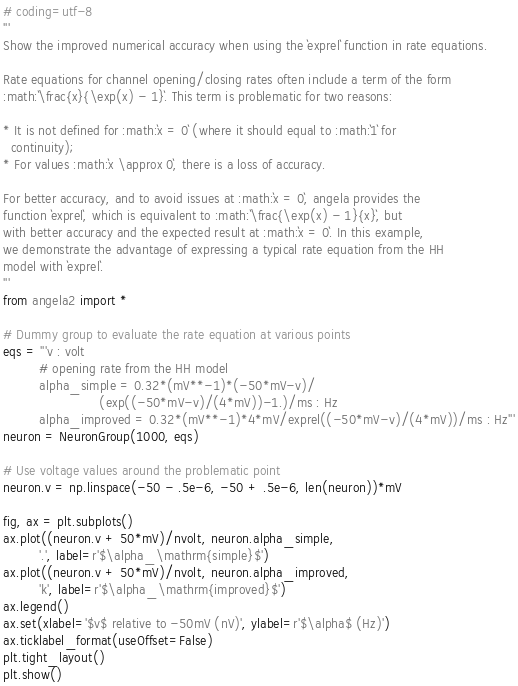<code> <loc_0><loc_0><loc_500><loc_500><_Python_># coding=utf-8
'''
Show the improved numerical accuracy when using the `exprel` function in rate equations.

Rate equations for channel opening/closing rates often include a term of the form
:math:`\frac{x}{\exp(x) - 1}`. This term is problematic for two reasons:

* It is not defined for :math:`x = 0` (where it should equal to :math:`1` for
  continuity);
* For values :math:`x \approx 0`, there is a loss of accuracy.

For better accuracy, and to avoid issues at :math:`x = 0`, angela provides the
function `exprel`, which is equivalent to :math:`\frac{\exp(x) - 1}{x}`, but
with better accuracy and the expected result at :math:`x = 0`. In this example,
we demonstrate the advantage of expressing a typical rate equation from the HH
model with `exprel`.
'''
from angela2 import *

# Dummy group to evaluate the rate equation at various points
eqs = '''v : volt
         # opening rate from the HH model
         alpha_simple = 0.32*(mV**-1)*(-50*mV-v)/
                        (exp((-50*mV-v)/(4*mV))-1.)/ms : Hz
         alpha_improved = 0.32*(mV**-1)*4*mV/exprel((-50*mV-v)/(4*mV))/ms : Hz'''
neuron = NeuronGroup(1000, eqs)

# Use voltage values around the problematic point
neuron.v = np.linspace(-50 - .5e-6, -50 + .5e-6, len(neuron))*mV

fig, ax = plt.subplots()
ax.plot((neuron.v + 50*mV)/nvolt, neuron.alpha_simple,
         '.', label=r'$\alpha_\mathrm{simple}$')
ax.plot((neuron.v + 50*mV)/nvolt, neuron.alpha_improved,
         'k', label=r'$\alpha_\mathrm{improved}$')
ax.legend()
ax.set(xlabel='$v$ relative to -50mV (nV)', ylabel=r'$\alpha$ (Hz)')
ax.ticklabel_format(useOffset=False)
plt.tight_layout()
plt.show()
</code> 